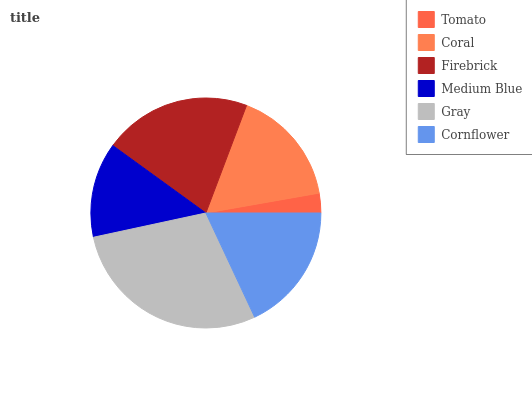Is Tomato the minimum?
Answer yes or no. Yes. Is Gray the maximum?
Answer yes or no. Yes. Is Coral the minimum?
Answer yes or no. No. Is Coral the maximum?
Answer yes or no. No. Is Coral greater than Tomato?
Answer yes or no. Yes. Is Tomato less than Coral?
Answer yes or no. Yes. Is Tomato greater than Coral?
Answer yes or no. No. Is Coral less than Tomato?
Answer yes or no. No. Is Cornflower the high median?
Answer yes or no. Yes. Is Coral the low median?
Answer yes or no. Yes. Is Tomato the high median?
Answer yes or no. No. Is Gray the low median?
Answer yes or no. No. 